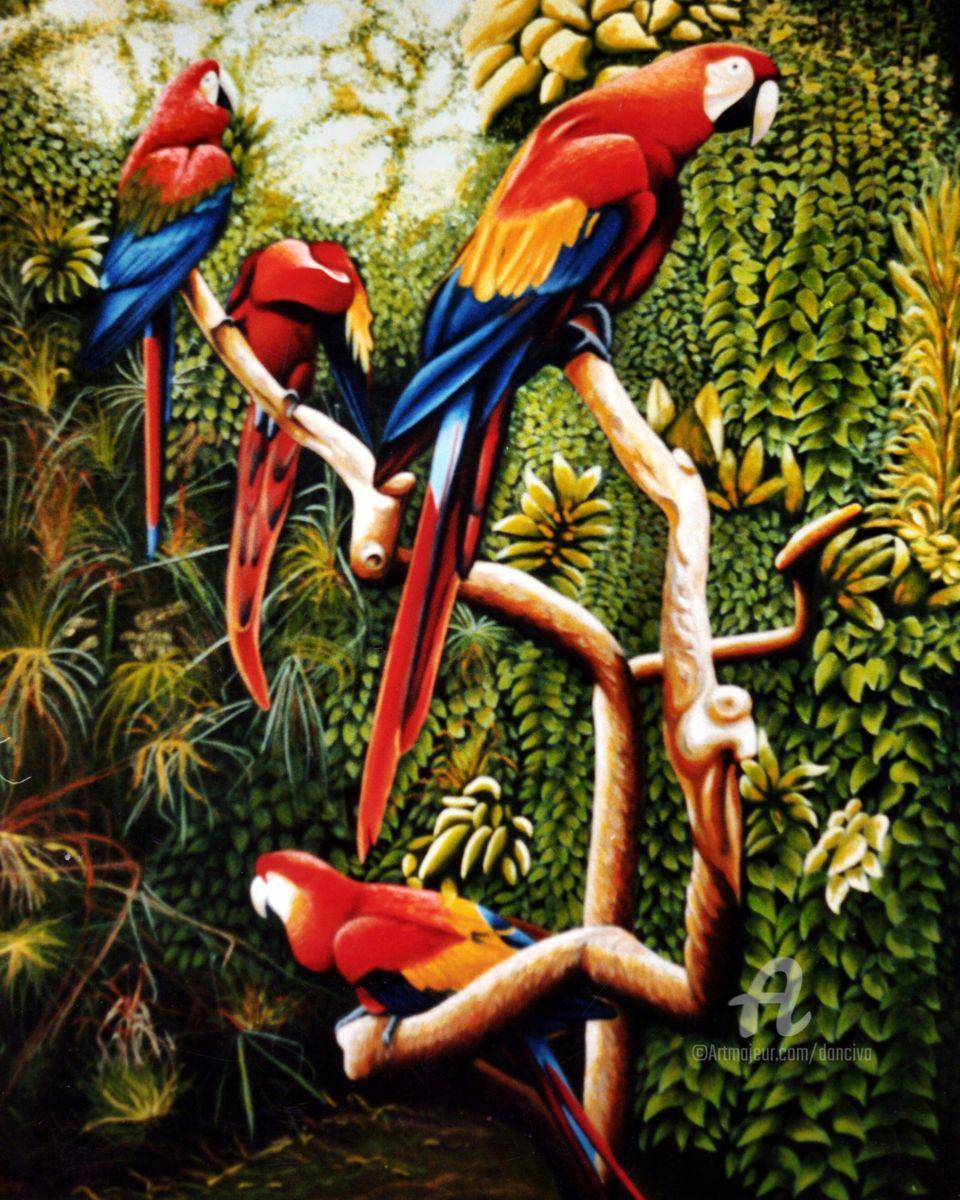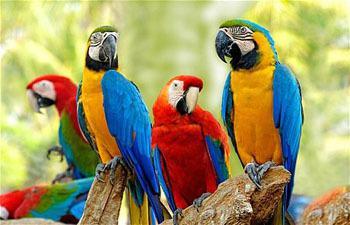The first image is the image on the left, the second image is the image on the right. Given the left and right images, does the statement "The parrot in the right image closest to the right side is blue and yellow." hold true? Answer yes or no. Yes. The first image is the image on the left, the second image is the image on the right. Evaluate the accuracy of this statement regarding the images: "There are six colorful birds perched on a piece of wood in the image on the left.". Is it true? Answer yes or no. No. 